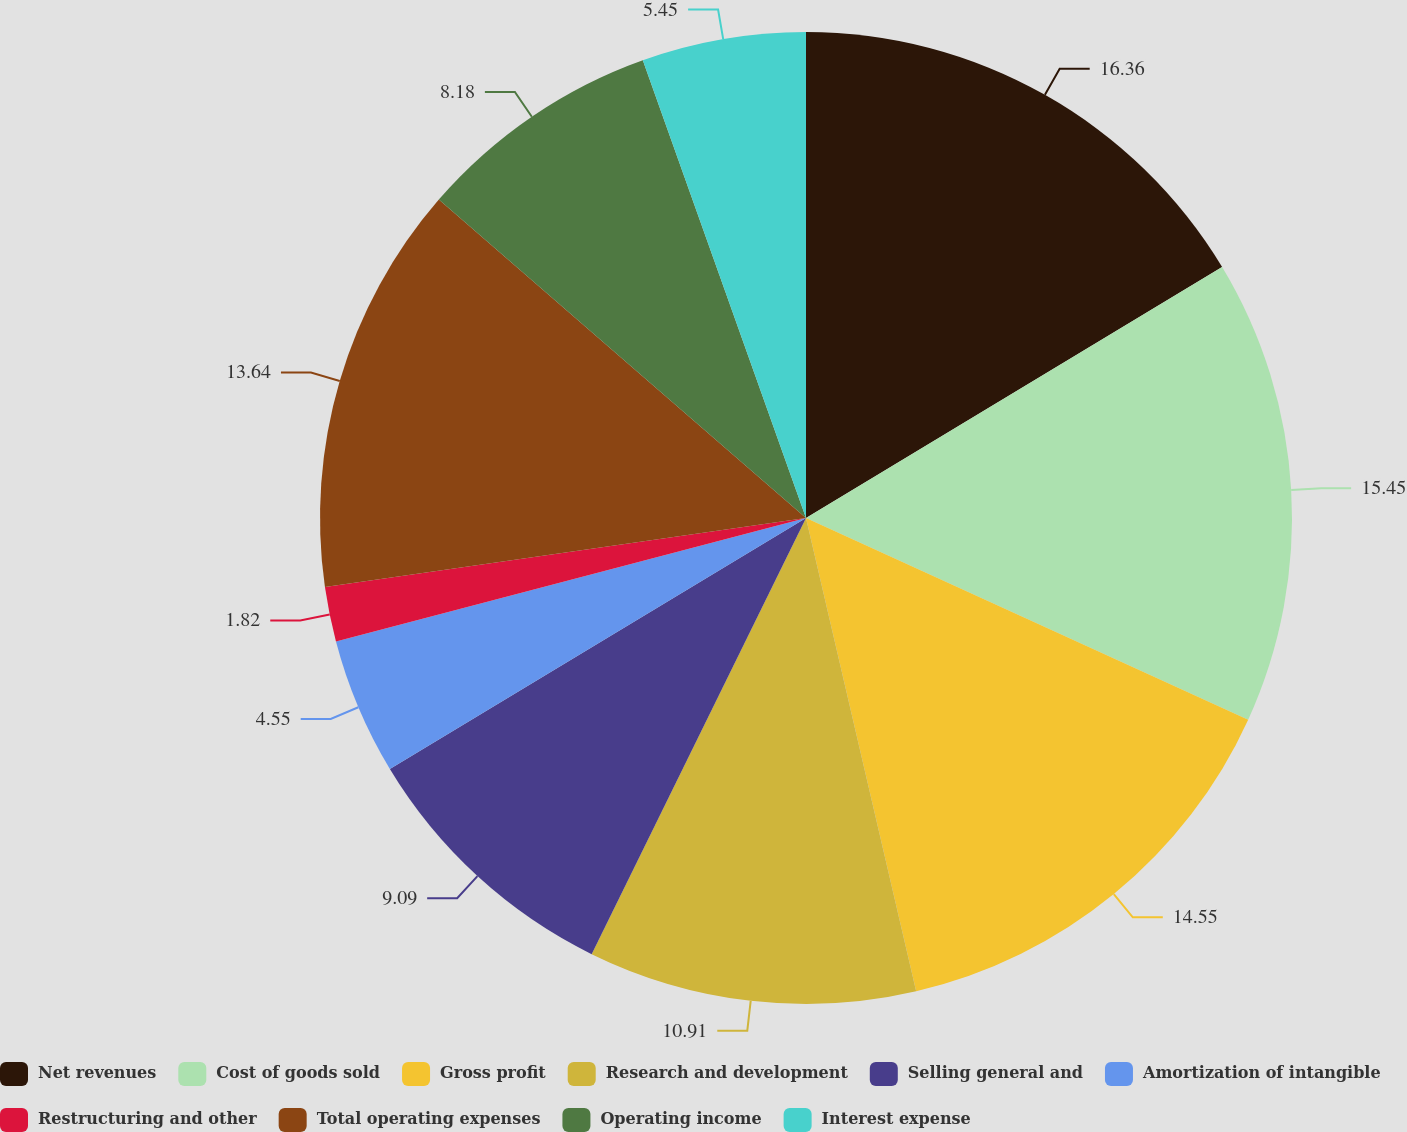Convert chart to OTSL. <chart><loc_0><loc_0><loc_500><loc_500><pie_chart><fcel>Net revenues<fcel>Cost of goods sold<fcel>Gross profit<fcel>Research and development<fcel>Selling general and<fcel>Amortization of intangible<fcel>Restructuring and other<fcel>Total operating expenses<fcel>Operating income<fcel>Interest expense<nl><fcel>16.36%<fcel>15.45%<fcel>14.55%<fcel>10.91%<fcel>9.09%<fcel>4.55%<fcel>1.82%<fcel>13.64%<fcel>8.18%<fcel>5.45%<nl></chart> 